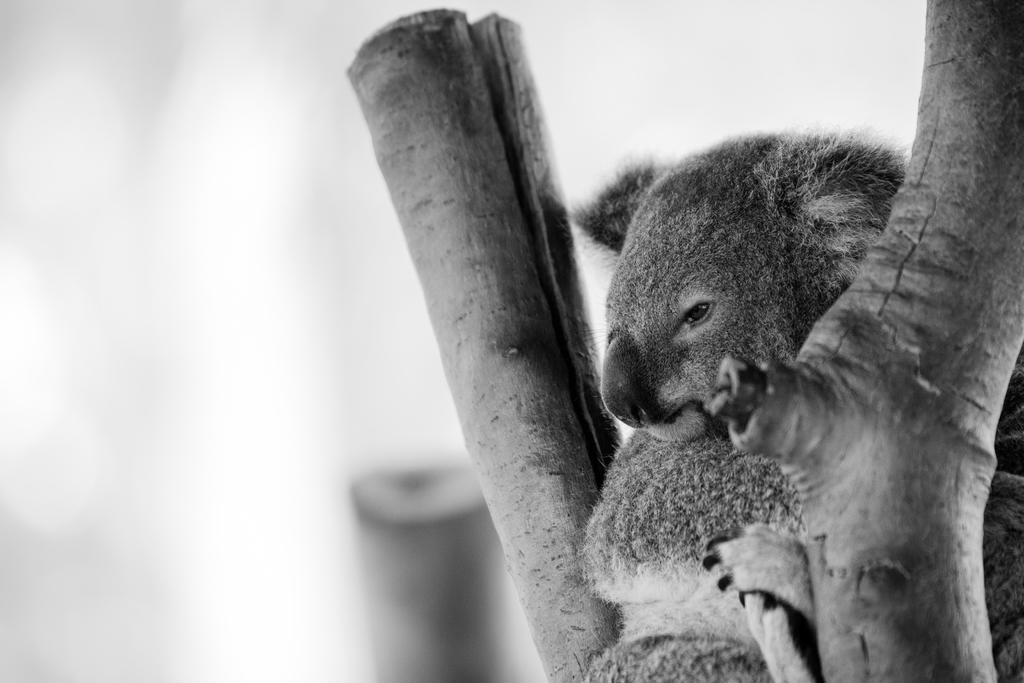Please provide a concise description of this image. This is the picture of a black and white image and we can see an animal and the tree branches and in the background the image is blurred. 